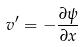<formula> <loc_0><loc_0><loc_500><loc_500>v ^ { \prime } = - \frac { \partial \psi } { \partial x }</formula> 